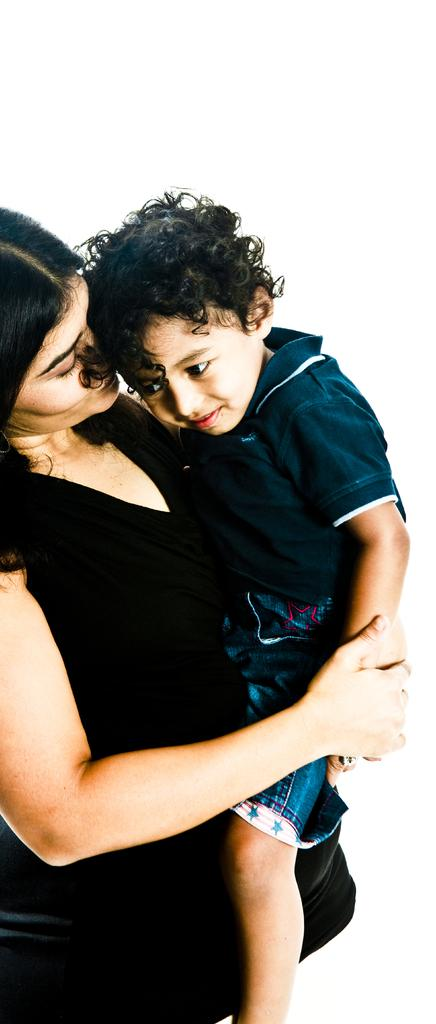Who is the main subject in the image? There is a woman in the image. What is the woman wearing? The woman is wearing a black dress. What is the woman doing in the image? The woman is holding a kid. What is the color of the background in the image? The background in the image is white. What invention is the woman demonstrating in the image? There is no invention being demonstrated in the image; the woman is simply holding a kid. Can you see any fairies in the image? There are no fairies present in the image. 